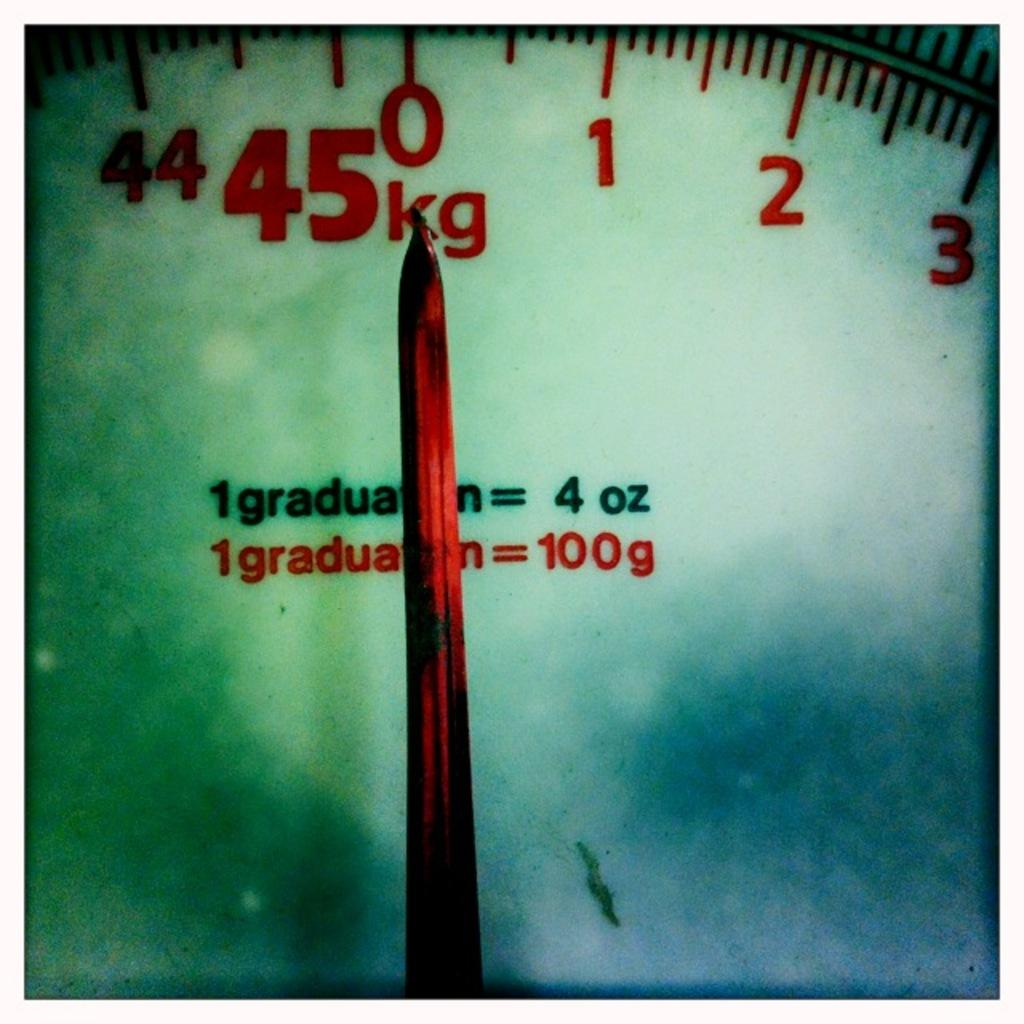<image>
Write a terse but informative summary of the picture. A scale dial that goes up to 45 kg has a red needle and points to zero. 